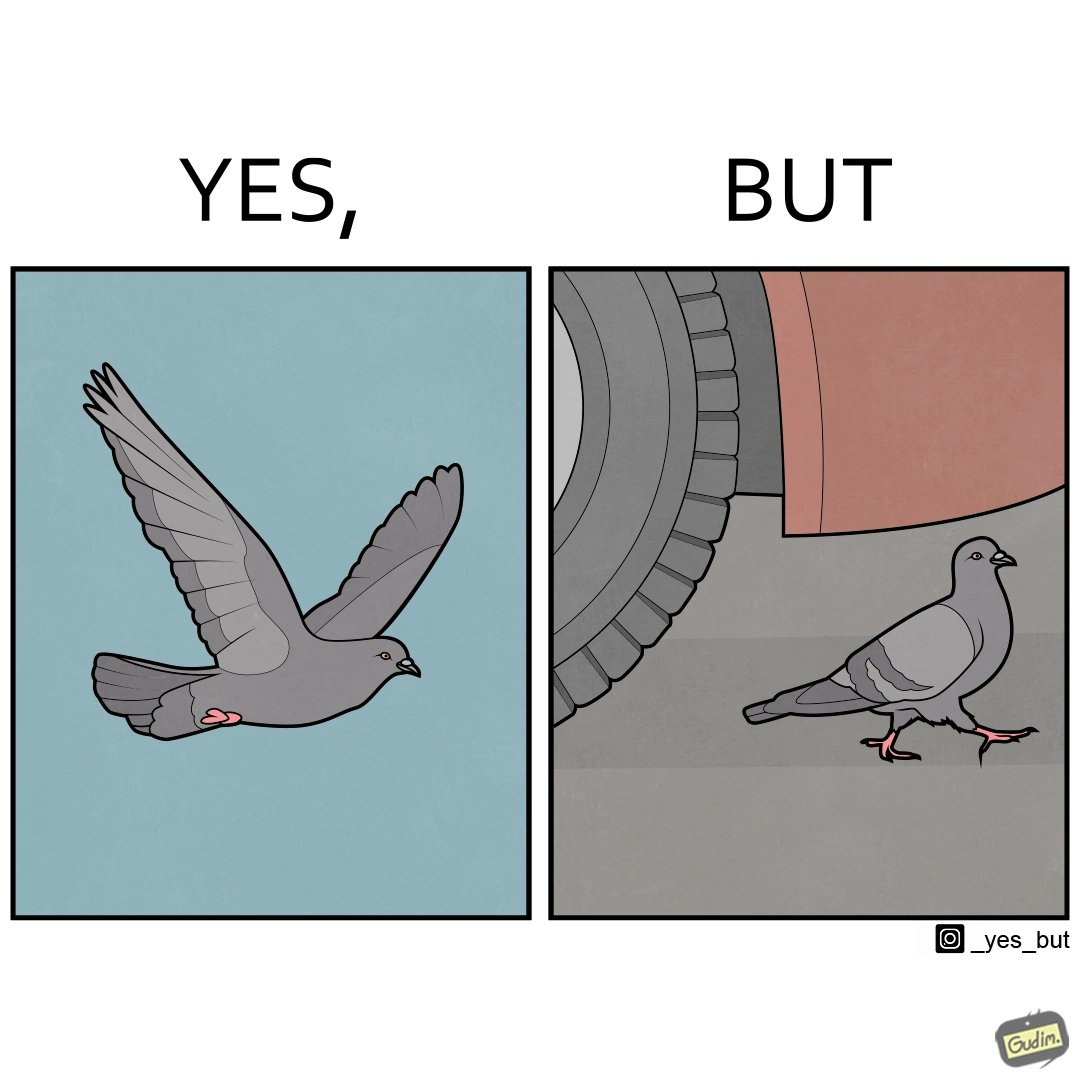Would you classify this image as satirical? Yes, this image is satirical. 